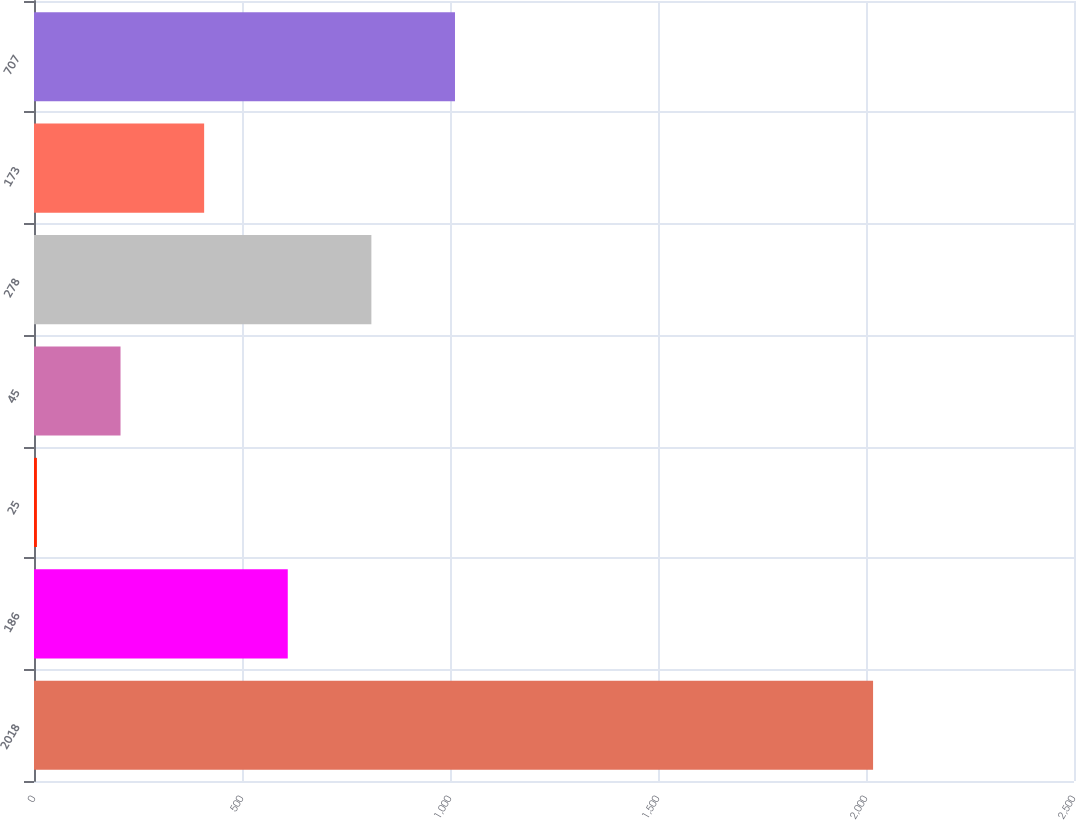<chart> <loc_0><loc_0><loc_500><loc_500><bar_chart><fcel>2018<fcel>186<fcel>25<fcel>45<fcel>278<fcel>173<fcel>707<nl><fcel>2017<fcel>610<fcel>7<fcel>208<fcel>811<fcel>409<fcel>1012<nl></chart> 